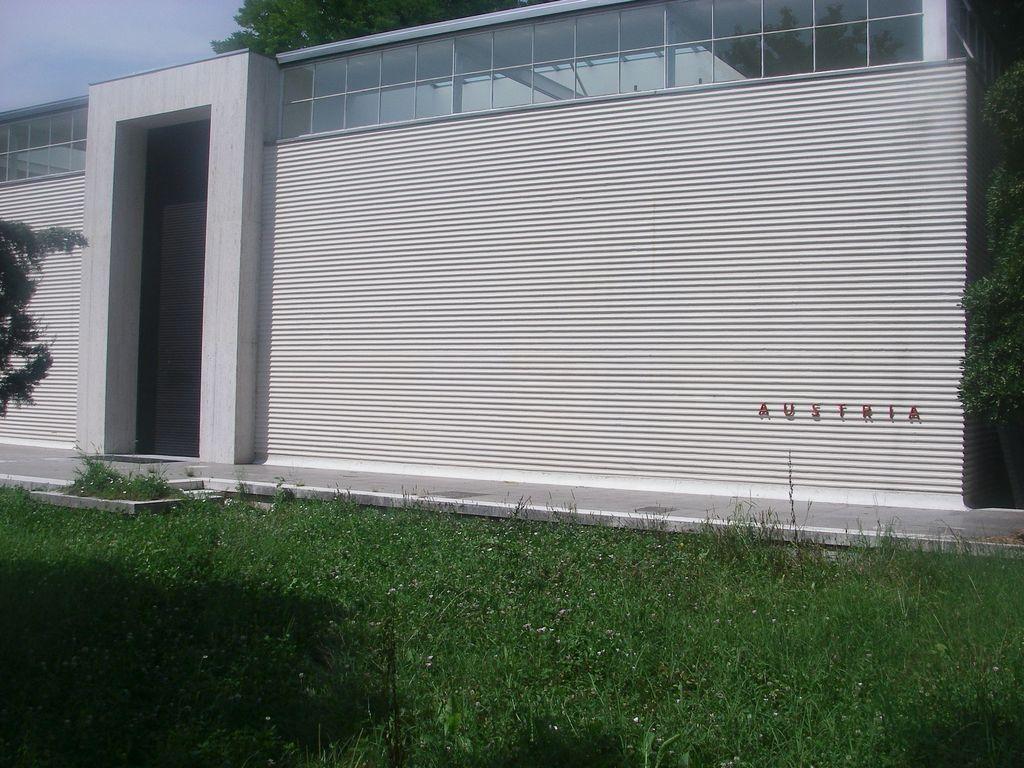Can you describe this image briefly? In this image, I can see a house and there is the grass. On the right side of the image, I can see a name board to the wall. In the background, there are trees and the sky. 